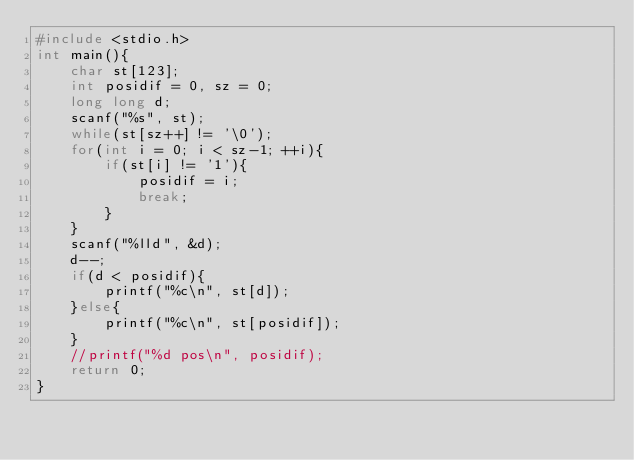<code> <loc_0><loc_0><loc_500><loc_500><_C_>#include <stdio.h>
int main(){
	char st[123];
	int posidif = 0, sz = 0;
	long long d;
	scanf("%s", st);
	while(st[sz++] != '\0');
	for(int i = 0; i < sz-1; ++i){
		if(st[i] != '1'){
			posidif = i;
			break;
		}
	}
	scanf("%lld", &d);
	d--;
	if(d < posidif){
		printf("%c\n", st[d]);
	}else{
		printf("%c\n", st[posidif]);
	}
	//printf("%d pos\n", posidif);
	return 0;
}
</code> 